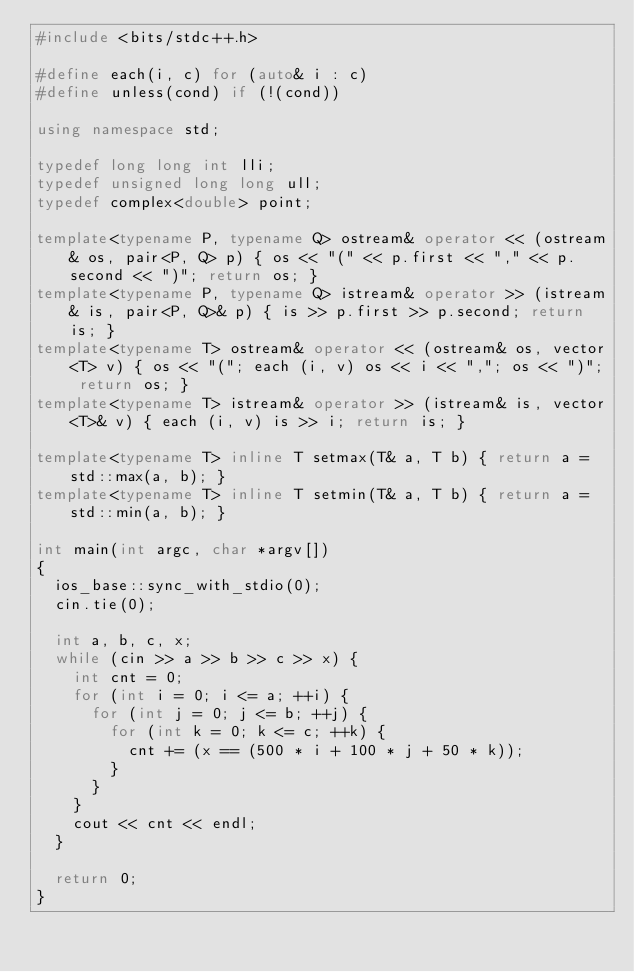<code> <loc_0><loc_0><loc_500><loc_500><_C++_>#include <bits/stdc++.h>

#define each(i, c) for (auto& i : c)
#define unless(cond) if (!(cond))

using namespace std;

typedef long long int lli;
typedef unsigned long long ull;
typedef complex<double> point;

template<typename P, typename Q> ostream& operator << (ostream& os, pair<P, Q> p) { os << "(" << p.first << "," << p.second << ")"; return os; }
template<typename P, typename Q> istream& operator >> (istream& is, pair<P, Q>& p) { is >> p.first >> p.second; return is; }
template<typename T> ostream& operator << (ostream& os, vector<T> v) { os << "("; each (i, v) os << i << ","; os << ")"; return os; }
template<typename T> istream& operator >> (istream& is, vector<T>& v) { each (i, v) is >> i; return is; }

template<typename T> inline T setmax(T& a, T b) { return a = std::max(a, b); }
template<typename T> inline T setmin(T& a, T b) { return a = std::min(a, b); }

int main(int argc, char *argv[])
{
  ios_base::sync_with_stdio(0);
  cin.tie(0);

  int a, b, c, x;
  while (cin >> a >> b >> c >> x) {
    int cnt = 0;
    for (int i = 0; i <= a; ++i) {
      for (int j = 0; j <= b; ++j) {
        for (int k = 0; k <= c; ++k) {
          cnt += (x == (500 * i + 100 * j + 50 * k));
        }
      }
    }
    cout << cnt << endl;
  }
  
  return 0;
}
</code> 